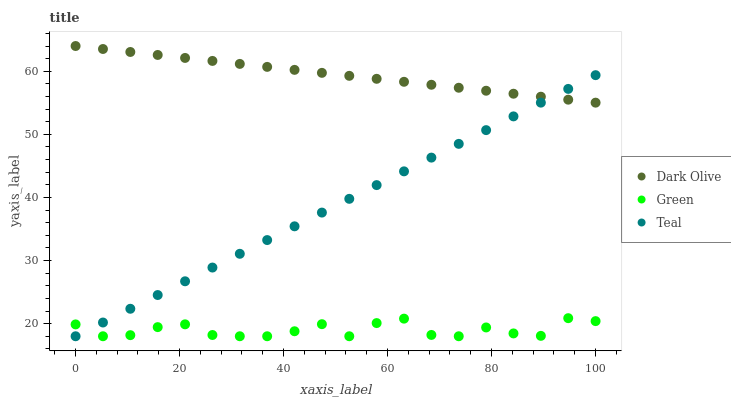Does Green have the minimum area under the curve?
Answer yes or no. Yes. Does Dark Olive have the maximum area under the curve?
Answer yes or no. Yes. Does Teal have the minimum area under the curve?
Answer yes or no. No. Does Teal have the maximum area under the curve?
Answer yes or no. No. Is Dark Olive the smoothest?
Answer yes or no. Yes. Is Green the roughest?
Answer yes or no. Yes. Is Teal the smoothest?
Answer yes or no. No. Is Teal the roughest?
Answer yes or no. No. Does Green have the lowest value?
Answer yes or no. Yes. Does Dark Olive have the highest value?
Answer yes or no. Yes. Does Teal have the highest value?
Answer yes or no. No. Is Green less than Dark Olive?
Answer yes or no. Yes. Is Dark Olive greater than Green?
Answer yes or no. Yes. Does Teal intersect Green?
Answer yes or no. Yes. Is Teal less than Green?
Answer yes or no. No. Is Teal greater than Green?
Answer yes or no. No. Does Green intersect Dark Olive?
Answer yes or no. No. 